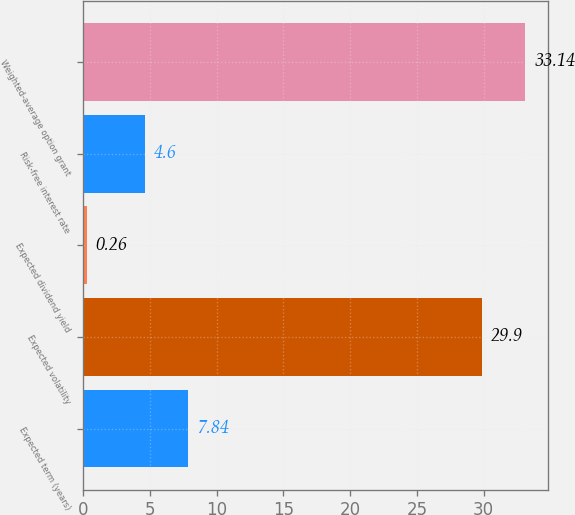Convert chart to OTSL. <chart><loc_0><loc_0><loc_500><loc_500><bar_chart><fcel>Expected term (years)<fcel>Expected volatility<fcel>Expected dividend yield<fcel>Risk-free interest rate<fcel>Weighted-average option grant<nl><fcel>7.84<fcel>29.9<fcel>0.26<fcel>4.6<fcel>33.14<nl></chart> 